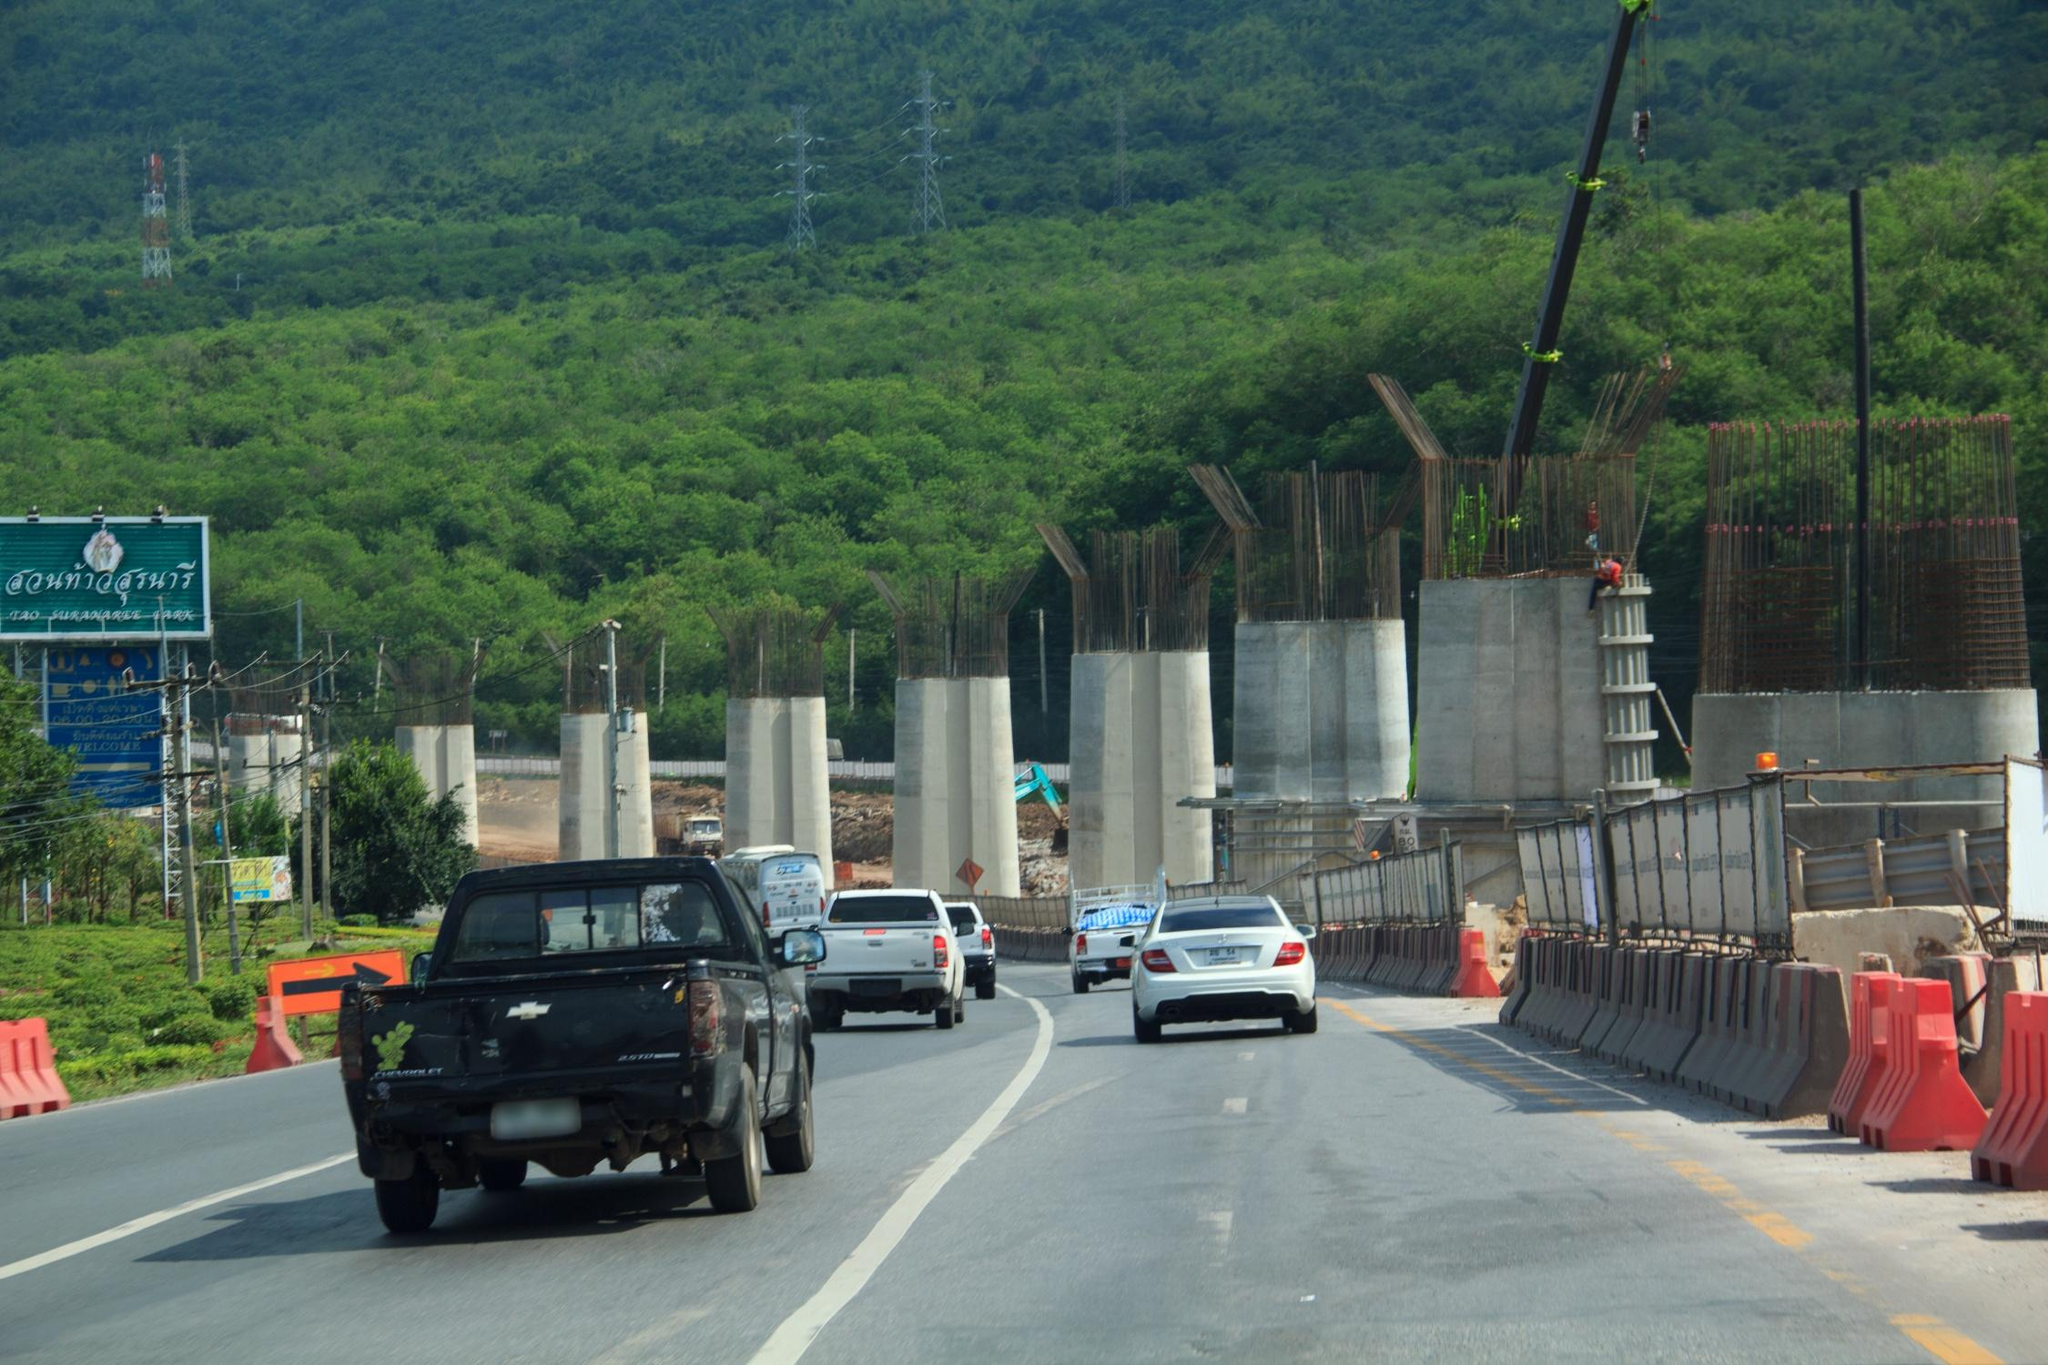What are the key elements in this picture? The image vividly portrays a highway under comprehensive construction within a mountainous region. Noticeably, the partially constructed roadway is flanked by prominent orange traffic barriers typically seen at construction sites. Multiple construction vehicles and towering cranes are dispersed throughout the scene, indicating significant ongoing progress. Surrounding the construction zone, a verdant landscape filled with verdant green trees offers a striking contrast to the raw, unfinished road. The sky above is a serene blue, hinting that the photo was captured during daylight hours. The perspective of the photograph, seemingly taken from the view of a car traveling on the highway, grants an immersive experience and a sense of anticipation for the completed road ahead. The identifier 'sa_1641' seen in the image does not provide enough contextual information to specifically identify the landmark or location depicted. 